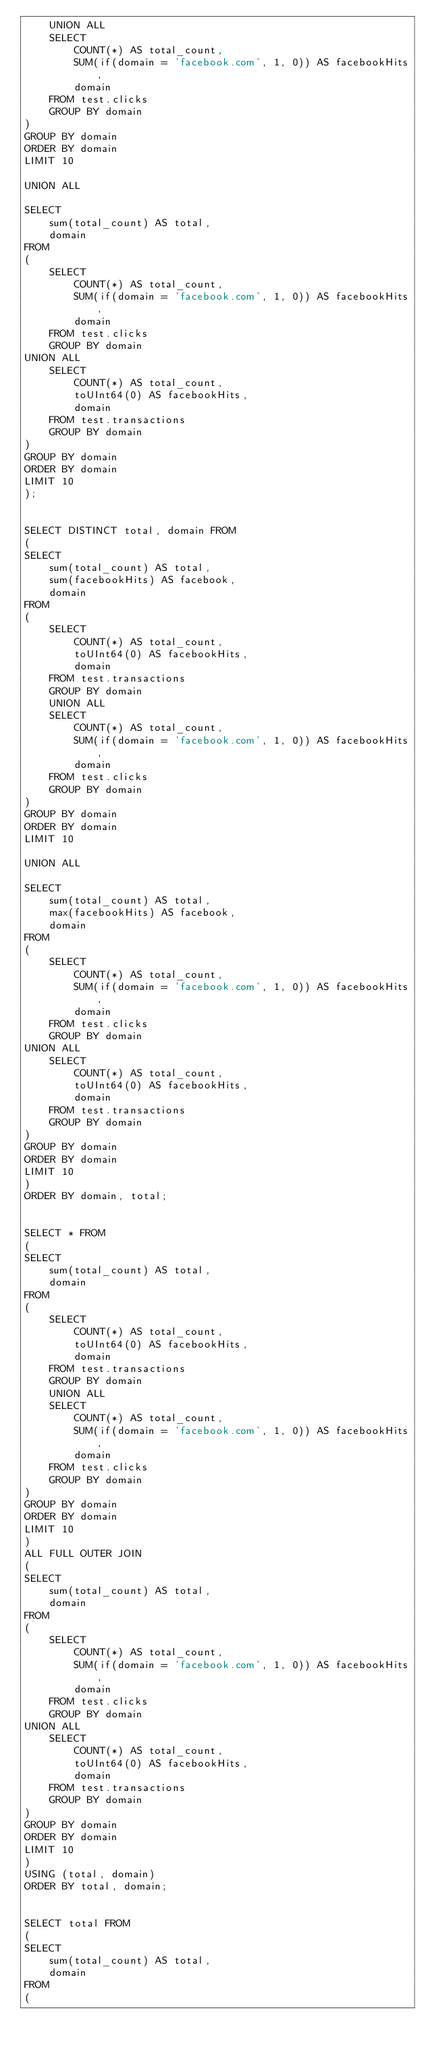Convert code to text. <code><loc_0><loc_0><loc_500><loc_500><_SQL_>    UNION ALL 
    SELECT 
        COUNT(*) AS total_count, 
        SUM(if(domain = 'facebook.com', 1, 0)) AS facebookHits, 
        domain
    FROM test.clicks 
    GROUP BY domain
) 
GROUP BY domain
ORDER BY domain
LIMIT 10

UNION ALL

SELECT 
    sum(total_count) AS total, 
    domain
FROM 
(
    SELECT 
        COUNT(*) AS total_count, 
        SUM(if(domain = 'facebook.com', 1, 0)) AS facebookHits, 
        domain
    FROM test.clicks 
    GROUP BY domain
UNION ALL 
    SELECT 
        COUNT(*) AS total_count, 
        toUInt64(0) AS facebookHits, 
        domain
    FROM test.transactions 
    GROUP BY domain
) 
GROUP BY domain
ORDER BY domain
LIMIT 10
);


SELECT DISTINCT total, domain FROM
(
SELECT 
    sum(total_count) AS total, 
    sum(facebookHits) AS facebook,
    domain
FROM 
(
    SELECT 
        COUNT(*) AS total_count, 
        toUInt64(0) AS facebookHits, 
        domain
    FROM test.transactions 
    GROUP BY domain
    UNION ALL 
    SELECT 
        COUNT(*) AS total_count, 
        SUM(if(domain = 'facebook.com', 1, 0)) AS facebookHits, 
        domain
    FROM test.clicks 
    GROUP BY domain
) 
GROUP BY domain
ORDER BY domain
LIMIT 10

UNION ALL

SELECT 
    sum(total_count) AS total, 
    max(facebookHits) AS facebook,
    domain
FROM 
(
    SELECT 
        COUNT(*) AS total_count, 
        SUM(if(domain = 'facebook.com', 1, 0)) AS facebookHits, 
        domain
    FROM test.clicks 
    GROUP BY domain
UNION ALL 
    SELECT 
        COUNT(*) AS total_count, 
        toUInt64(0) AS facebookHits, 
        domain
    FROM test.transactions 
    GROUP BY domain
) 
GROUP BY domain
ORDER BY domain
LIMIT 10
)
ORDER BY domain, total;


SELECT * FROM
(
SELECT 
    sum(total_count) AS total, 
    domain
FROM 
(
    SELECT 
        COUNT(*) AS total_count, 
        toUInt64(0) AS facebookHits, 
        domain
    FROM test.transactions 
    GROUP BY domain
    UNION ALL 
    SELECT 
        COUNT(*) AS total_count, 
        SUM(if(domain = 'facebook.com', 1, 0)) AS facebookHits, 
        domain
    FROM test.clicks 
    GROUP BY domain
) 
GROUP BY domain
ORDER BY domain
LIMIT 10
)
ALL FULL OUTER JOIN
(
SELECT 
    sum(total_count) AS total, 
    domain
FROM 
(
    SELECT 
        COUNT(*) AS total_count, 
        SUM(if(domain = 'facebook.com', 1, 0)) AS facebookHits, 
        domain
    FROM test.clicks 
    GROUP BY domain
UNION ALL 
    SELECT 
        COUNT(*) AS total_count, 
        toUInt64(0) AS facebookHits, 
        domain
    FROM test.transactions 
    GROUP BY domain
) 
GROUP BY domain
ORDER BY domain
LIMIT 10
)
USING (total, domain)
ORDER BY total, domain;


SELECT total FROM
(
SELECT 
    sum(total_count) AS total, 
    domain
FROM 
(</code> 